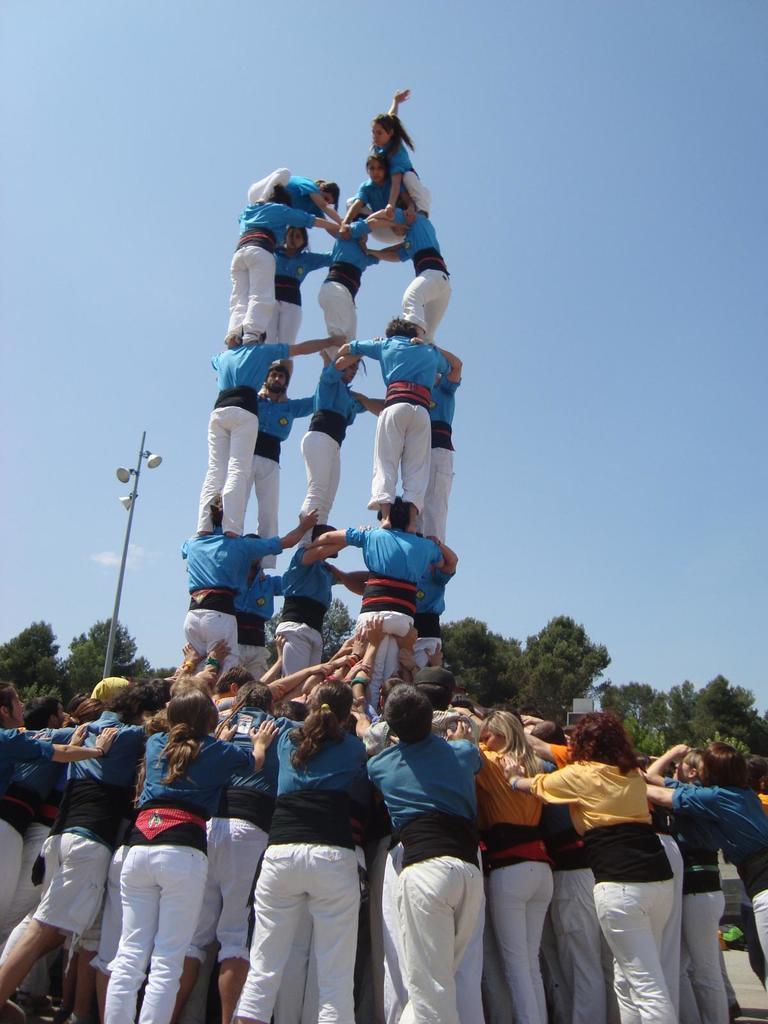Please provide a concise description of this image. In the image there are many people standing above each other forming a pyramid and in the background there are trees with a street light on the left side and above its sky. 